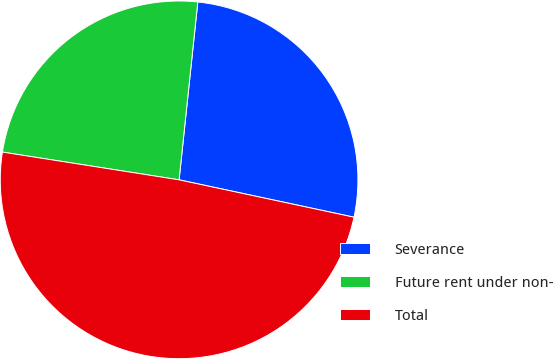Convert chart. <chart><loc_0><loc_0><loc_500><loc_500><pie_chart><fcel>Severance<fcel>Future rent under non-<fcel>Total<nl><fcel>26.68%<fcel>24.19%<fcel>49.13%<nl></chart> 